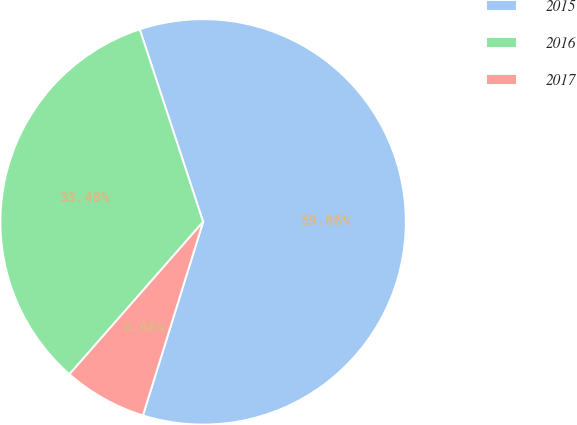<chart> <loc_0><loc_0><loc_500><loc_500><pie_chart><fcel>2015<fcel>2016<fcel>2017<nl><fcel>59.86%<fcel>33.48%<fcel>6.66%<nl></chart> 